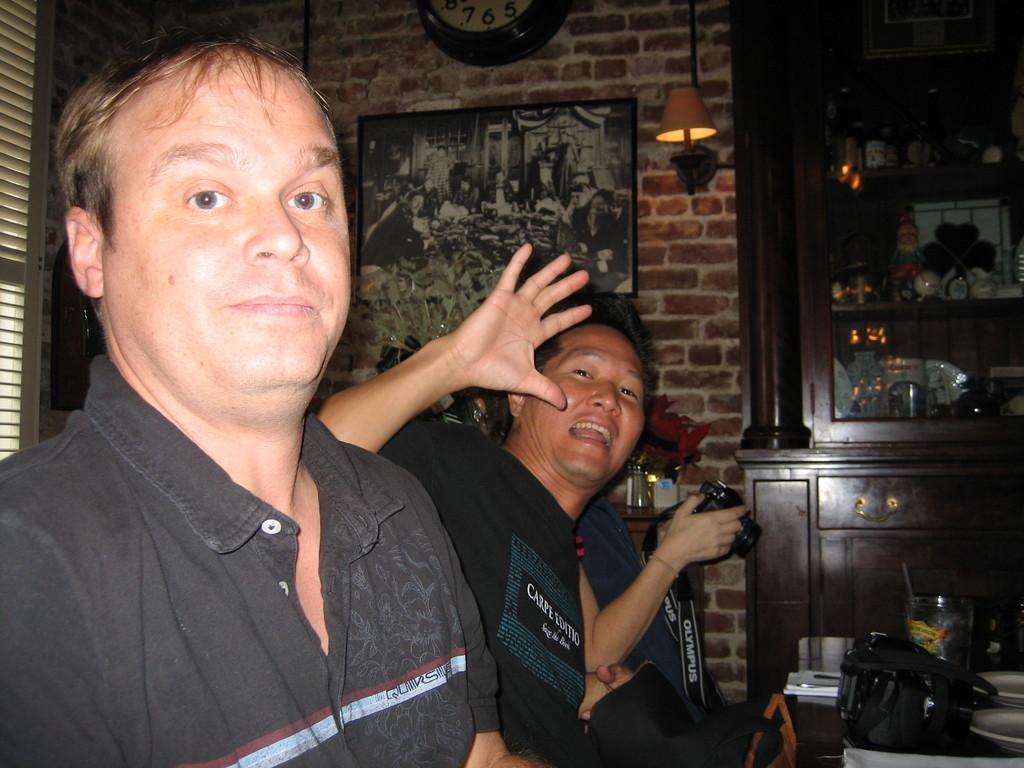In one or two sentences, can you explain what this image depicts? In this image on the left there is a man, he wears a shirt. In the middle there is a man, he wears a t shirt and there is a person, holding a camera. In the background there are cupboards, photo frame, lights, clock, wall, window, shelves, table plates and bag. 